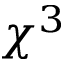<formula> <loc_0><loc_0><loc_500><loc_500>\chi ^ { 3 }</formula> 